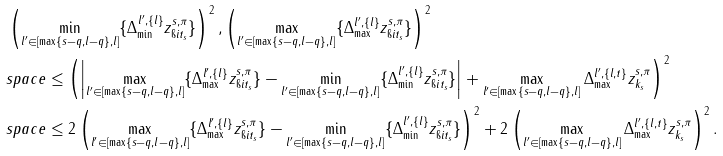<formula> <loc_0><loc_0><loc_500><loc_500>& \left ( \min _ { l ^ { \prime } \in [ \max \{ s - q , l - q \} , l ] } \{ \Delta _ { \min } ^ { l ^ { \prime } , \{ l \} } z _ { \i i t _ { s } } ^ { s , \pi } \} \right ) ^ { 2 } , \left ( \max _ { l ^ { \prime } \in [ \max \{ s - q , l - q \} , l ] } \{ \Delta _ { \max } ^ { l ^ { \prime } , \{ l \} } z _ { \i i t _ { s } } ^ { s , \pi } \} \right ) ^ { 2 } \\ & s p a c e \leq \left ( \left | \max _ { l ^ { \prime } \in [ \max \{ s - q , l - q \} , l ] } \{ \Delta _ { \max } ^ { l ^ { \prime } , \{ l \} } z _ { \i i t _ { s } } ^ { s , \pi } \} - \min _ { l ^ { \prime } \in [ \max \{ s - q , l - q \} , l ] } \{ \Delta _ { \min } ^ { l ^ { \prime } , \{ l \} } z _ { \i i t _ { s } } ^ { s , \pi } \} \right | + \max _ { l ^ { \prime } \in [ \max \{ s - q , l - q \} , l ] } \Delta ^ { l ^ { \prime } , \{ l , t \} } _ { \max } z ^ { s , \pi } _ { k _ { s } } \right ) ^ { 2 } \\ & s p a c e \leq 2 \left ( \max _ { l ^ { \prime } \in [ \max \{ s - q , l - q \} , l ] } \{ \Delta _ { \max } ^ { l ^ { \prime } , \{ l \} } z _ { \i i t _ { s } } ^ { s , \pi } \} - \min _ { l ^ { \prime } \in [ \max \{ s - q , l - q \} , l ] } \{ \Delta _ { \min } ^ { l ^ { \prime } , \{ l \} } z _ { \i i t _ { s } } ^ { s , \pi } \} \right ) ^ { 2 } + 2 \left ( \max _ { l ^ { \prime } \in [ \max \{ s - q , l - q \} , l ] } \Delta ^ { l ^ { \prime } , \{ l , t \} } _ { \max } z ^ { s , \pi } _ { k _ { s } } \right ) ^ { 2 } .</formula> 